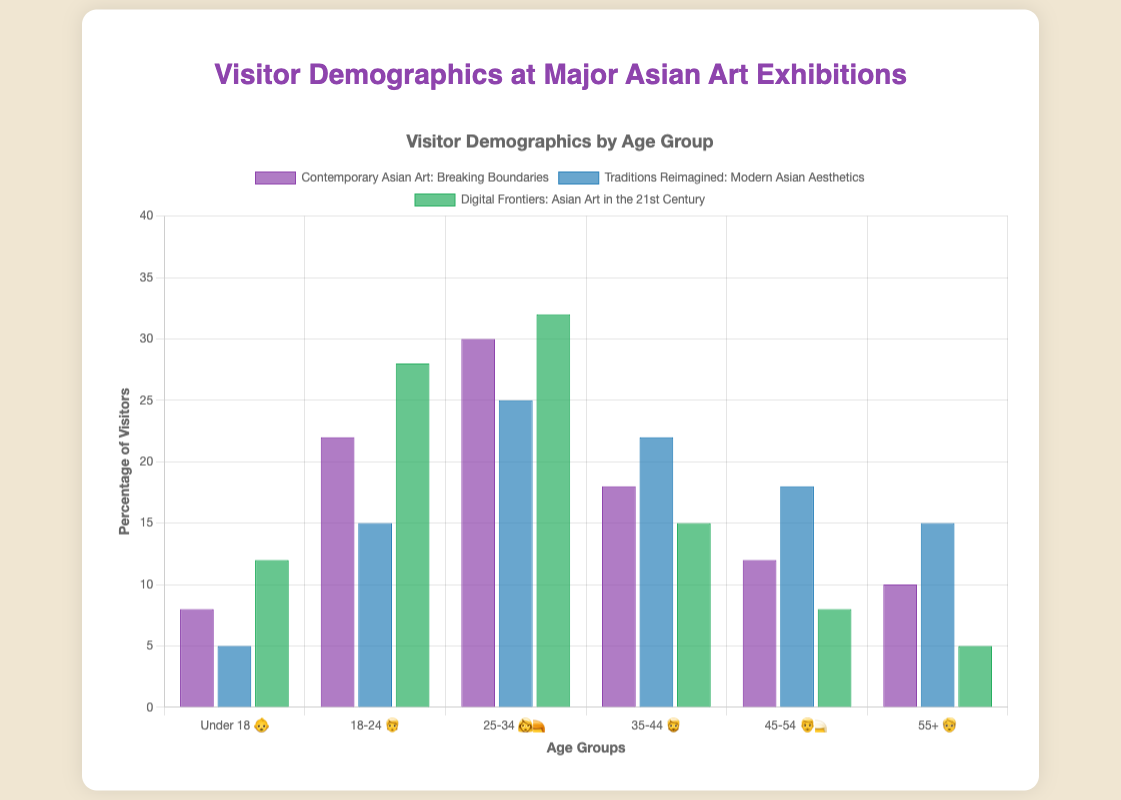Which age group had the highest percentage of visitors for "Contemporary Asian Art: Breaking Boundaries"? The figure shows a bar for each age group, and the bar labeled "25-34 👩‍🦰" is the tallest in this exhibition, indicating the highest percentage.
Answer: 25-34 👩‍🦰 What is the percentage difference between the "18-24 🧑" and "35-44 🧔" age groups for "Traditions Reimagined: Modern Asian Aesthetics"? The percentage for "18-24 🧑" is 15, and for "35-44 🧔" is 22. The difference is calculated as 22 - 15.
Answer: 7 In which exhibition does the "Under 18 👶" age group have the highest percentage? Comparing the "Under 18 👶" bars across all exhibitions, "Digital Frontiers: Asian Art in the 21st Century" has the tallest bar with 12%.
Answer: Digital Frontiers: Asian Art in the 21st Century Which exhibition had the lowest percentage of visitors in the "55+ 🧓" age group? Comparing the "55+ 🧓" bars, "Digital Frontiers: Asian Art in the 21st Century" has the shortest bar at 5%.
Answer: Digital Frontiers: Asian Art in the 21st Century What is the average percentage of visitors for the "45-54 👨‍🦳" age group across all exhibitions? Summing up the percentages: 12 (Contemporary) + 18 (Traditions) + 8 (Digital) gives 38. Dividing by the number of exhibitions (3) gives 38/3 ≈ 12.67.
Answer: 12.67 How many age groups have more than 20% visitors for the exhibition "Digital Frontiers: Asian Art in the 21st Century"? The age groups "18-24 🧑" (28%) and "25-34 👩‍🦰" (32%) both have more than 20%. That makes 2 age groups.
Answer: 2 Which exhibition had the most balanced distribution between the "55+ 🧓" and "Under 18 👶" age groups in terms of percentages? By comparing both percentages for each exhibition: "Contemporary" (10%, 8%), "Traditions" (15%, 5%), "Digital" (5%, 12%). "Contemporary" has the smallest difference (2%) between the two age groups.
Answer: Contemporary Asian Art: Breaking Boundaries What is the overall trend for the "25-34 👩‍🦰" age group across the three exhibitions? Observation of the "25-34 👩‍🦰" bars: 30% (Contemporary), 25% (Traditions), 32% (Digital). This group tends to be the highest among all age groups, consistently attracting significant visitors.
Answer: High and consistent 